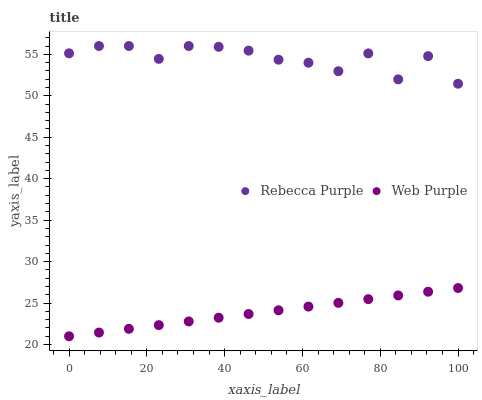Does Web Purple have the minimum area under the curve?
Answer yes or no. Yes. Does Rebecca Purple have the maximum area under the curve?
Answer yes or no. Yes. Does Rebecca Purple have the minimum area under the curve?
Answer yes or no. No. Is Web Purple the smoothest?
Answer yes or no. Yes. Is Rebecca Purple the roughest?
Answer yes or no. Yes. Is Rebecca Purple the smoothest?
Answer yes or no. No. Does Web Purple have the lowest value?
Answer yes or no. Yes. Does Rebecca Purple have the lowest value?
Answer yes or no. No. Does Rebecca Purple have the highest value?
Answer yes or no. Yes. Is Web Purple less than Rebecca Purple?
Answer yes or no. Yes. Is Rebecca Purple greater than Web Purple?
Answer yes or no. Yes. Does Web Purple intersect Rebecca Purple?
Answer yes or no. No. 